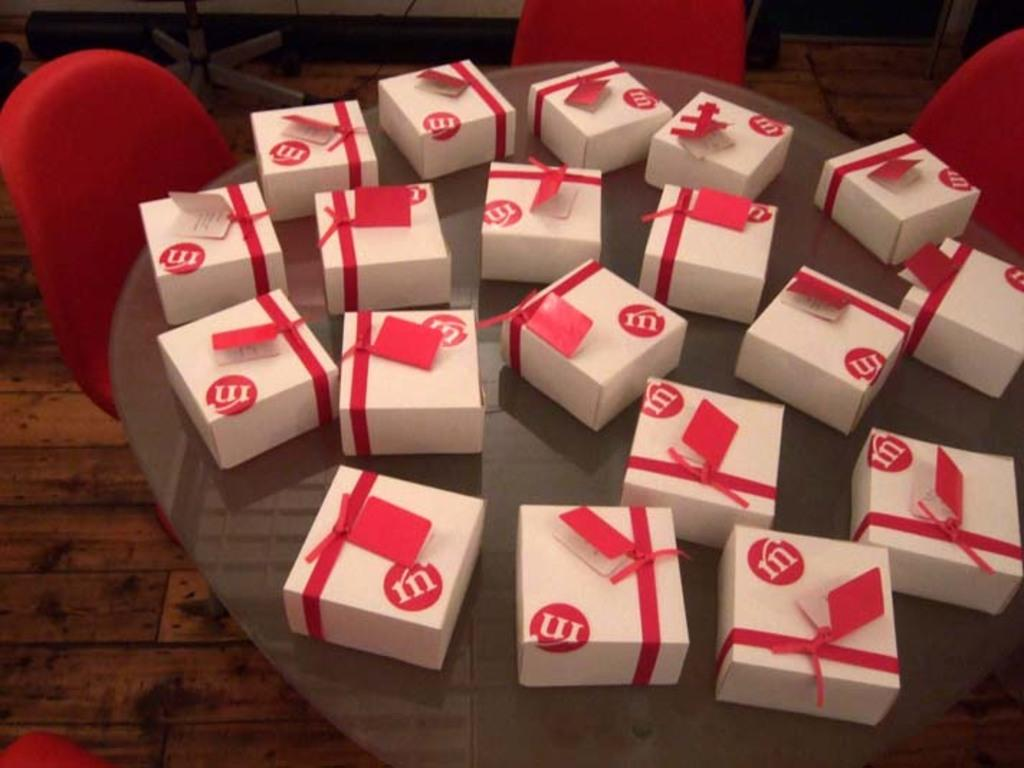What type of furniture is present in the image? There is a table and chairs in the image. What is on top of the table in the image? There are white color boxes on the table. What type of shoes are visible under the table in the image? There are no shoes visible under the table in the image. How much rice is in the white color boxes on the table? There is no rice mentioned or visible in the image; it only shows white color boxes on the table. 